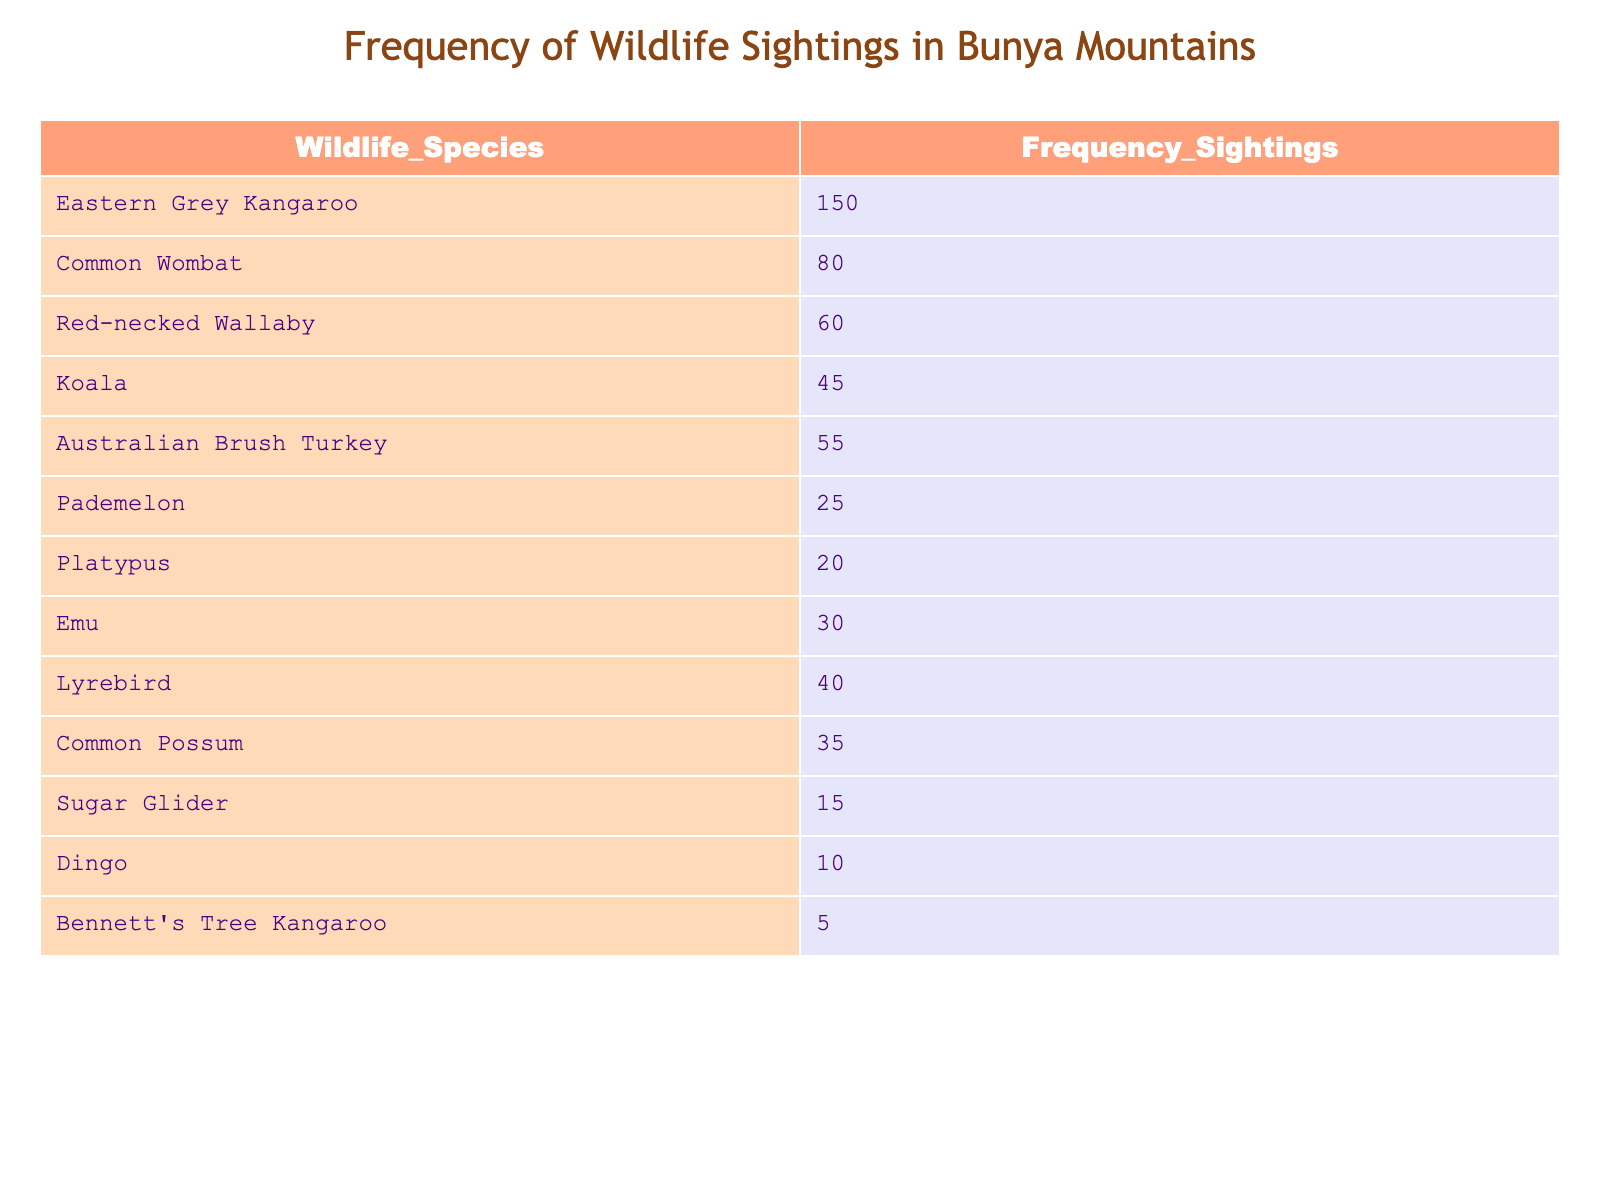What is the frequency of sightings for the Eastern Grey Kangaroo? The table lists the Eastern Grey Kangaroo under the Wildlife Species column and shows that it has a frequency of 150 sightings.
Answer: 150 Which species has the lowest frequency of sightings? The species with the lowest frequency in the table is Bennett's Tree Kangaroo, which has 5 sightings listed.
Answer: Bennett's Tree Kangaroo What is the total frequency of sightings for the top three most frequently sighted wildlife species? The top three species by frequency are Eastern Grey Kangaroo (150), Common Wombat (80), and Red-necked Wallaby (60). Adding these gives 150 + 80 + 60 = 290.
Answer: 290 Are there more sightings of Koalas or Lyrebirds? The table shows that there are 45 sightings of Koalas and 40 sightings of Lyrebirds. Since 45 is greater than 40, there are more sightings of Koalas.
Answer: Yes What is the difference in frequency of sightings between the Emu and the Pademelon? The frequency of sightings for Emu is 30 and for Pademelon is 25. The difference is calculated as 30 - 25 = 5.
Answer: 5 How many wildlife species reported have more than 30 sightings? From the table, the species with more than 30 sightings include Eastern Grey Kangaroo, Common Wombat, Red-necked Wallaby, Koala, Australian Brush Turkey, Emu, Common Possum, which totals 7 species.
Answer: 7 What is the average frequency of sightings for all listed wildlife species? To find the average, first sum up all the frequencies: 150 + 80 + 60 + 45 + 55 + 25 + 20 + 30 + 40 + 35 + 15 + 10 + 5 = 525. There are 13 species, so the average is 525 / 13 = approximately 40.38.
Answer: Approximately 40.38 Is the frequency of sightings for Common Possum higher than 30? According to the table, the frequency of sightings for Common Possum is 35, which is indeed higher than 30.
Answer: Yes Which two species have a combined frequency of sightings equal to or greater than 100? Looking at various pairs, if we combine Eastern Grey Kangaroo (150) and any other species, it exceeds 100. For example, Eastern Grey Kangaroo (150) and Common Wombat (80) together add up to 230.
Answer: Yes 